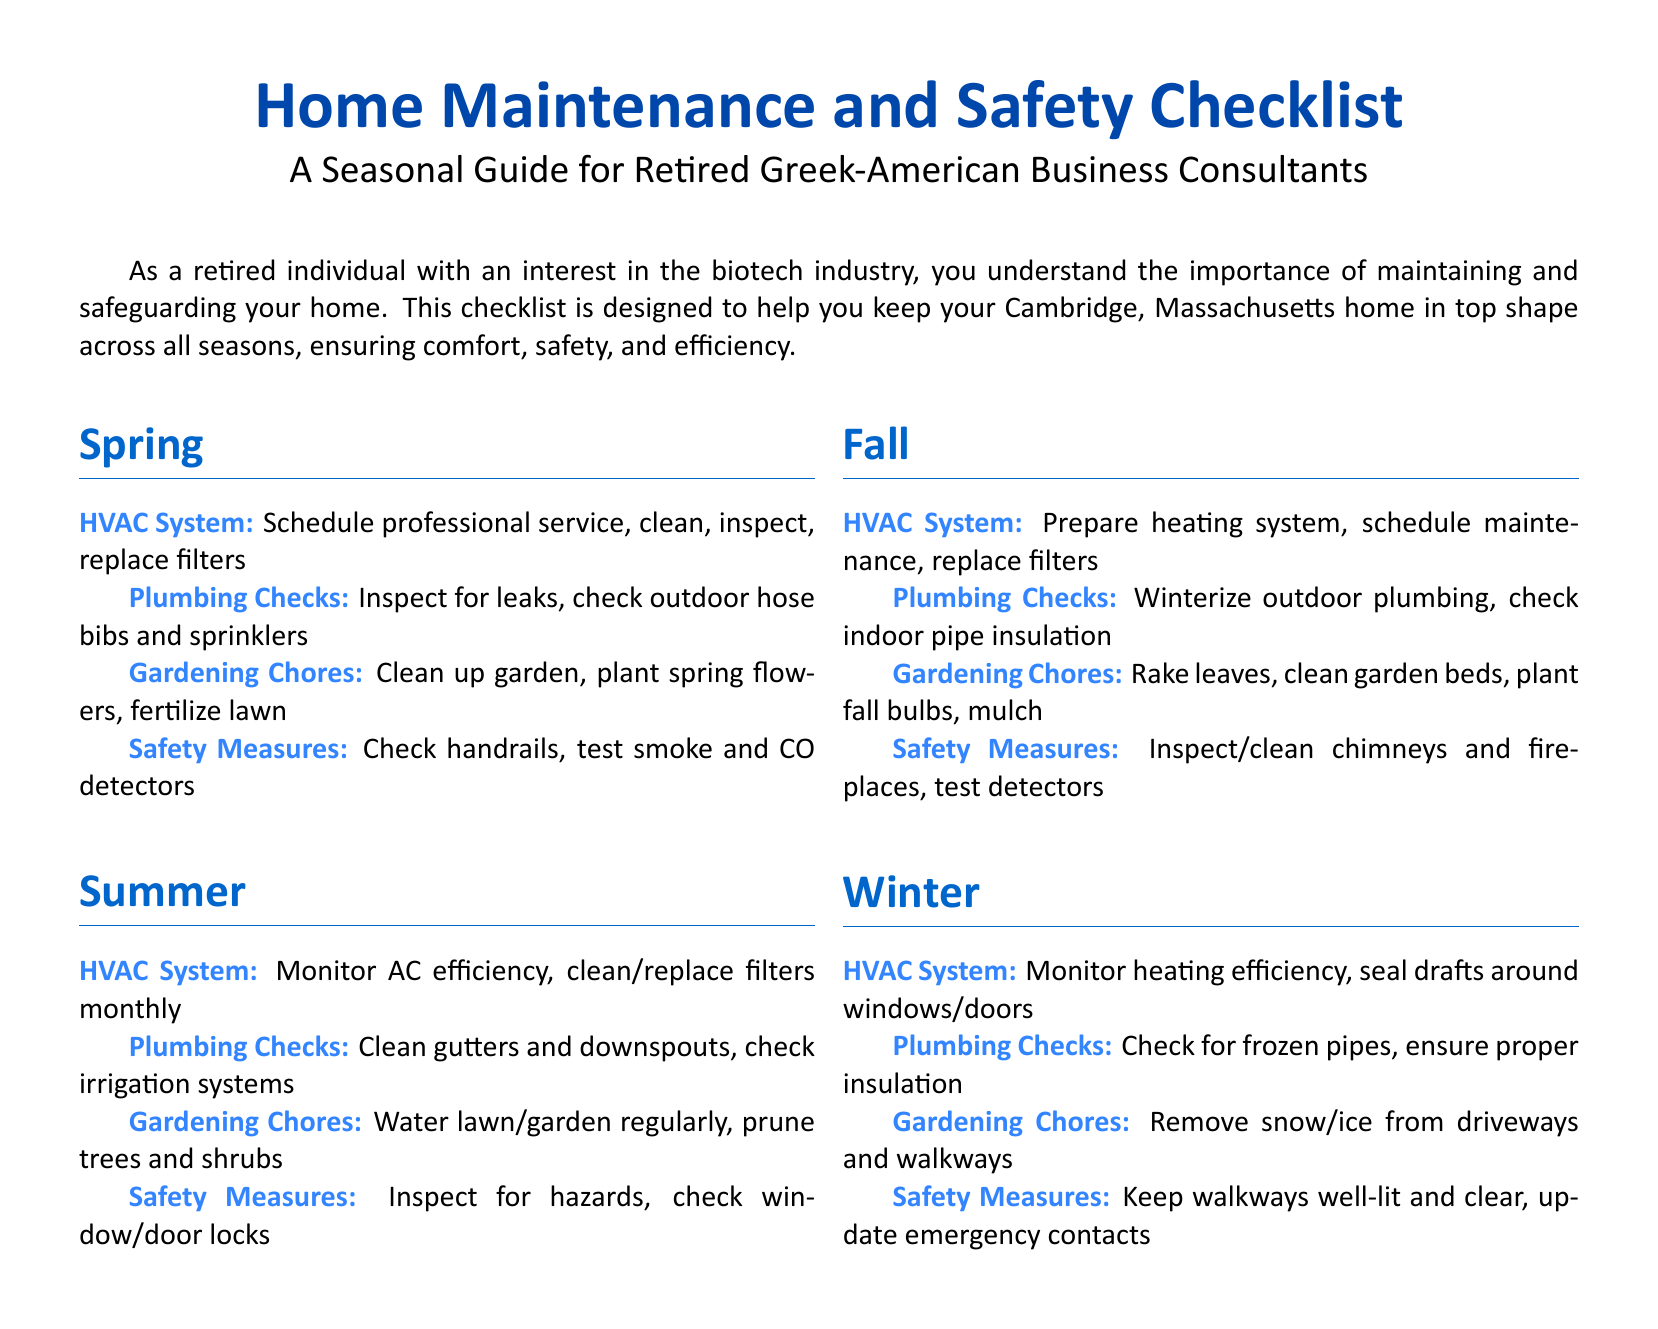What is the focus of the checklist? The checklist is intended for home maintenance and safety tasks throughout the seasons.
Answer: Home Maintenance and Safety How many sections are in the checklist? The checklist contains four seasonal sections: Spring, Summer, Fall, and Winter.
Answer: Four What is one of the gardening chores for Spring? The document lists specific gardening tasks for each season, and for Spring, one of the tasks is planting flowers.
Answer: Plant spring flowers What should be done with the HVAC system in Fall? The checklist specifies a task related to the HVAC system in Fall that includes preparing the heating system.
Answer: Prepare heating system In which season is it recommended to supervise heating efficiency? The checklist advises monitoring heating efficiency in Winter.
Answer: Winter What is a safety measure to check during Summer? The checklist includes inspecting for hazards during the Summer season.
Answer: Inspect for hazards What task is associated with plumbing checks in Winter? In the Winter section, the task related to plumbing checks involves checking for frozen pipes.
Answer: Check for frozen pipes How often should AC filters be replaced during Summer? The checklist recommends cleaning or replacing AC filters monthly in Summer.
Answer: Monthly What should be ensured in the Winter regarding walkways? The checklist denotes the importance of keeping walkways well-lit and clear in Winter for safety.
Answer: Well-lit and clear 